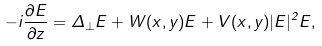<formula> <loc_0><loc_0><loc_500><loc_500>- i \frac { \partial E } { \partial z } = \Delta _ { \perp } E + W ( x , y ) E + V ( x , y ) | E | ^ { 2 } E ,</formula> 